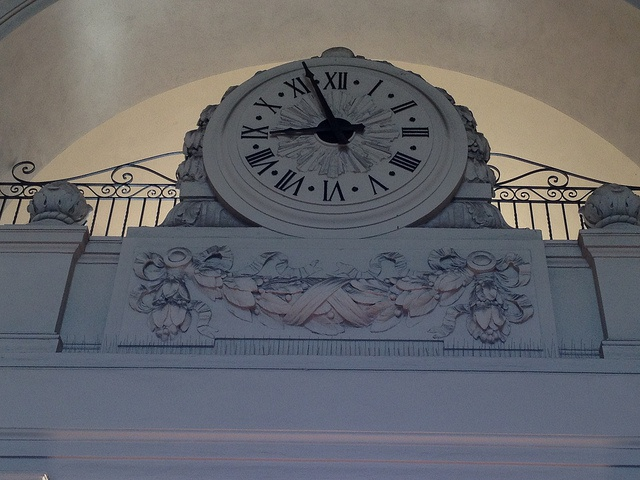Describe the objects in this image and their specific colors. I can see a clock in gray and black tones in this image. 